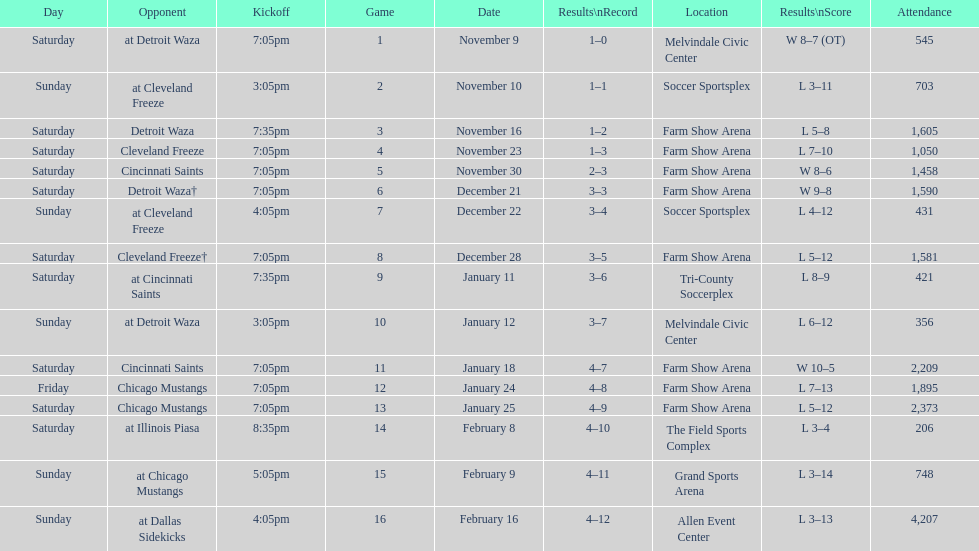What is the date of the game after december 22? December 28. 